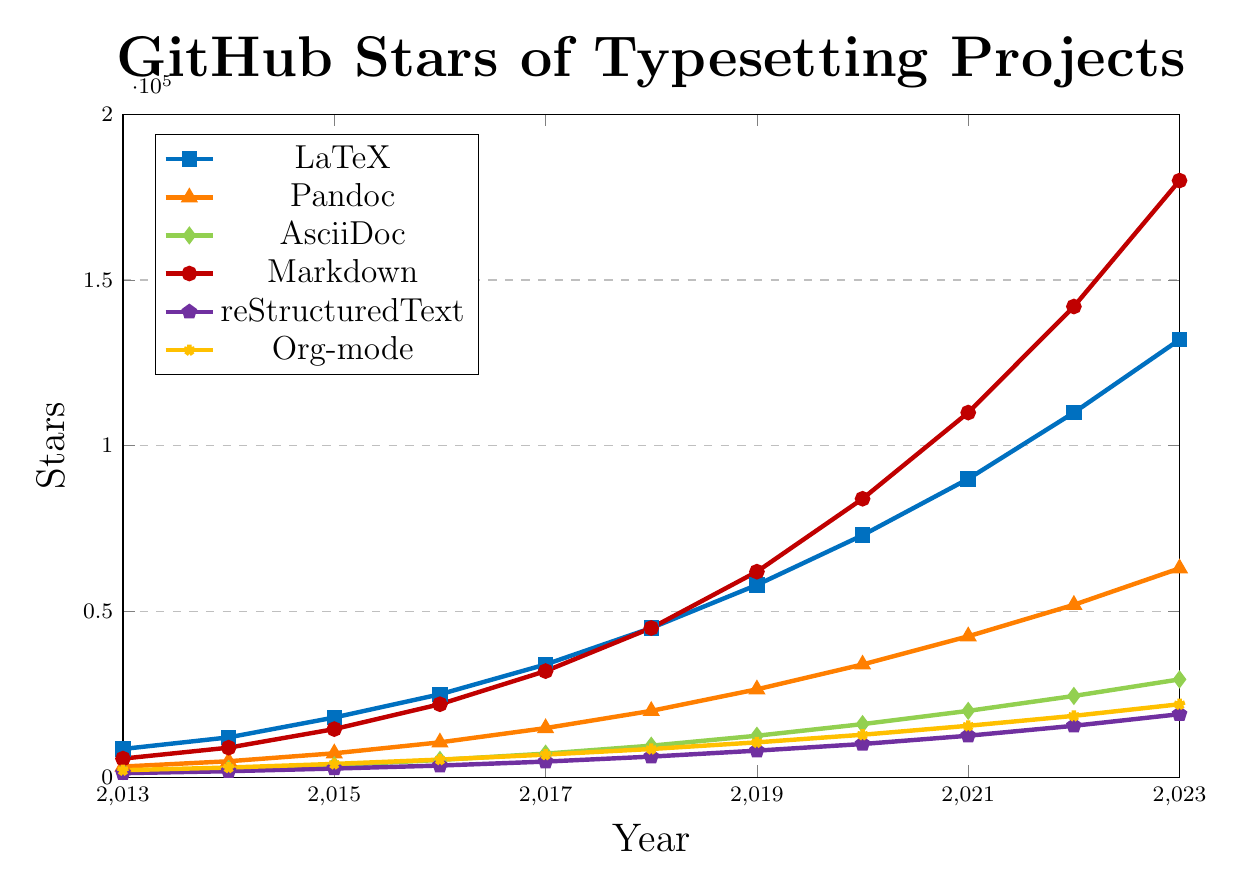What project had the highest number of GitHub stars in 2017? By looking at the figure, we can see that Markdown had the highest number of stars in 2017, shown by the red line which reaches 32,000 stars.
Answer: Markdown Which two projects have the closest number of GitHub stars in 2023? Referring to the figure, the projects Org-mode and reStructuredText have close numbers of stars in 2023, with Org-mode at 22,000 stars and reStructuredText at 19,000 stars; these values are closer to each other compared to other projects.
Answer: Org-mode and reStructuredText Which project had a steeper increase in stars from 2019 to 2020, LaTeX or Pandoc? By observing the slopes of the LaTeX and Pandoc lines between 2019 and 2020, LaTeX had a steeper increase. LaTeX increased from 58,000 to 73,000 (15,000 stars), while Pandoc increased from 26,500 to 34,000 (7,500 stars).
Answer: LaTeX What colors represent LaTeX and reStructuredText in the plot? LaTeX is represented by the blue line with square markers, and reStructuredText is represented by the purple line with pentagon markers.
Answer: Blue (LaTeX) and Purple (reStructuredText) Calculate the difference in GitHub stars between Markdown and AsciiDoc in 2023. In 2023, Markdown has 180,000 stars while AsciiDoc has 29,500 stars. The difference in stars is 180,000 - 29,500 = 150,500 stars.
Answer: 150,500 stars Which project saw the biggest relative growth in stars from 2013 to 2023? To determine the relative growth, we compare the 2023 stars to the 2013 stars for each project: LaTeX (132,000/8,500), Pandoc (63,000/3,200), AsciiDoc (29,500/1,800), Markdown (180,000/5,600), reStructuredText (19,000/1,200), and Org-mode (22,000/2,100). The project with the highest ratio is AsciiDoc with a ratio of approximately 16.39.
Answer: AsciiDoc How many more stars does Pandoc have than Org-mode in 2021? In 2021, Pandoc has 42,500 stars and Org-mode has 15,500 stars. Therefore, Pandoc has 42,500 - 15,500 = 27,000 more stars than Org-mode.
Answer: 27,000 stars 